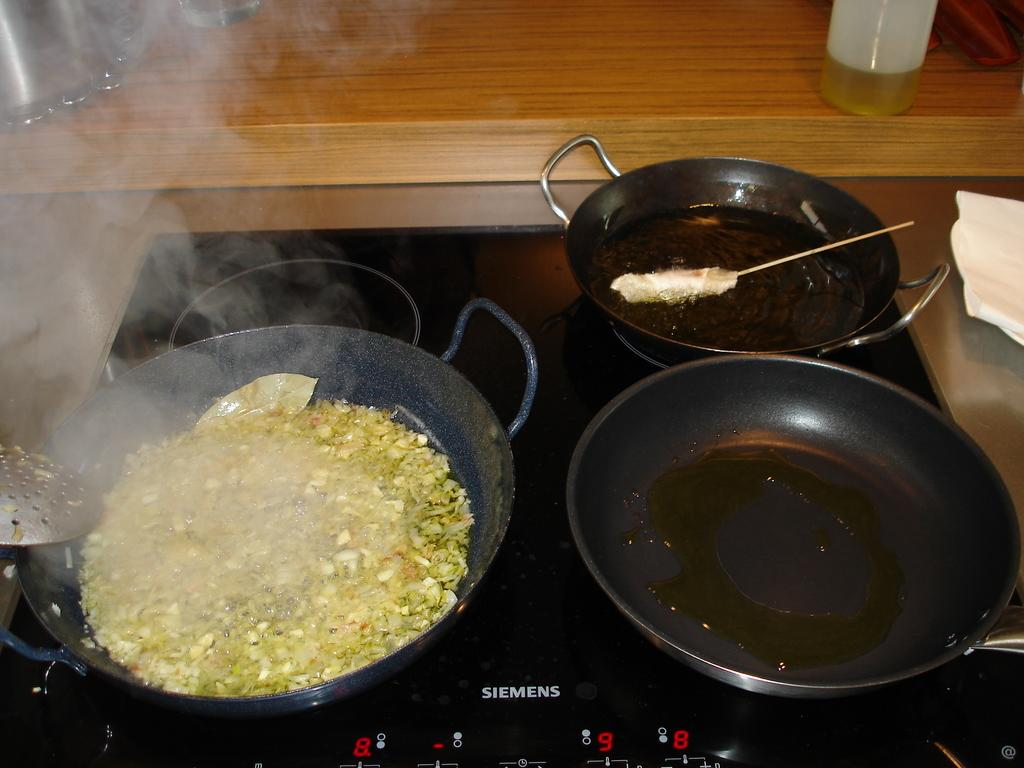What is being cooked on the gas stove in the image? The image does not show what is being cooked in the pans on the gas stove. What type of surface is visible in the background of the image? There is a wooden surface in the background of the image. What is placed on the wooden surface in the background? There is a plastic container on the wooden surface in the background. What type of protest is happening in the image? There is no protest present in the image; it shows cooking pans on a gas stove and a plastic container on a wooden surface. How many leaves can be seen in the image? There are no leaves visible in the image. 